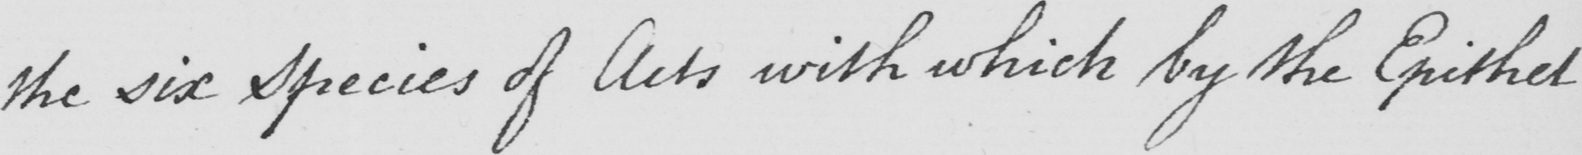What text is written in this handwritten line? the six Species of Acts with which by the Epithet 